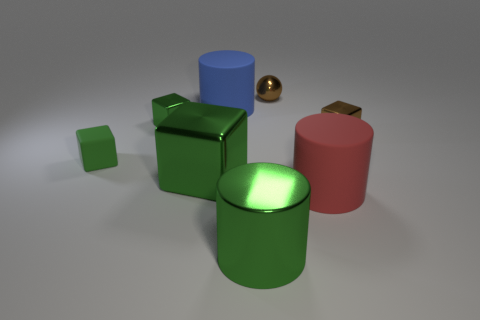Subtract all green cubes. How many were subtracted if there are1green cubes left? 2 Subtract all cyan cylinders. How many green blocks are left? 3 Subtract 1 blocks. How many blocks are left? 3 Add 2 purple things. How many objects exist? 10 Subtract all balls. How many objects are left? 7 Subtract all tiny rubber objects. Subtract all big blue cylinders. How many objects are left? 6 Add 5 green cylinders. How many green cylinders are left? 6 Add 3 green metallic cylinders. How many green metallic cylinders exist? 4 Subtract 0 yellow cylinders. How many objects are left? 8 